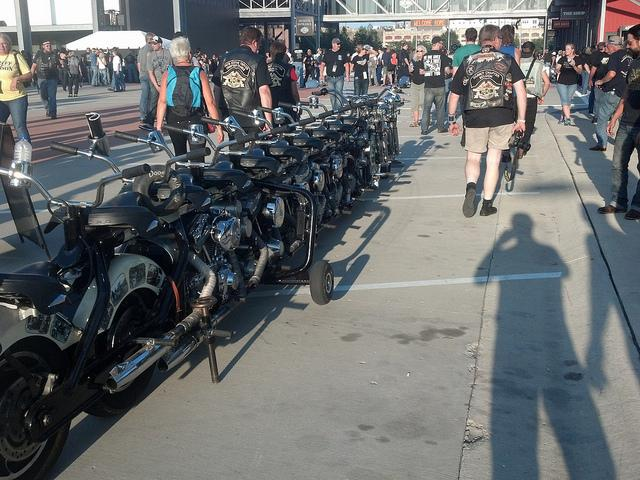What event will the people participate in? Please explain your reasoning. motorcycle parade. There are tons of motorcycles in the street. 